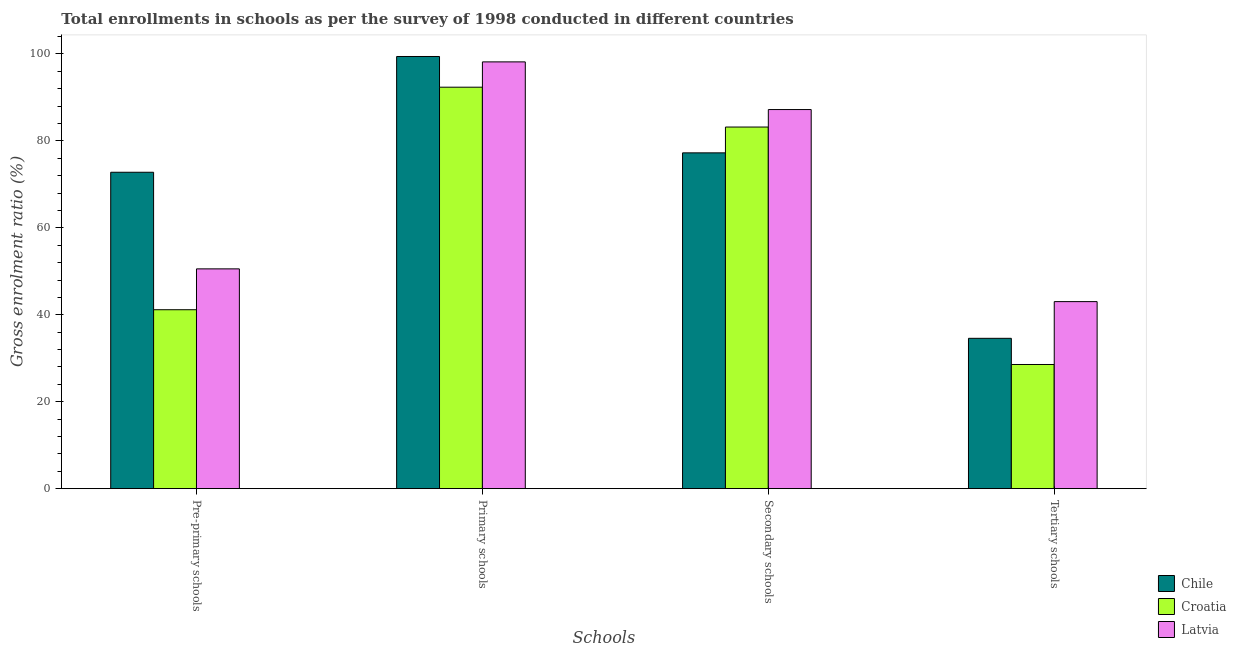How many different coloured bars are there?
Provide a succinct answer. 3. Are the number of bars on each tick of the X-axis equal?
Make the answer very short. Yes. How many bars are there on the 4th tick from the left?
Your response must be concise. 3. What is the label of the 4th group of bars from the left?
Make the answer very short. Tertiary schools. What is the gross enrolment ratio in secondary schools in Latvia?
Give a very brief answer. 87.21. Across all countries, what is the maximum gross enrolment ratio in primary schools?
Your response must be concise. 99.42. Across all countries, what is the minimum gross enrolment ratio in tertiary schools?
Your answer should be very brief. 28.57. In which country was the gross enrolment ratio in secondary schools maximum?
Make the answer very short. Latvia. In which country was the gross enrolment ratio in secondary schools minimum?
Provide a succinct answer. Chile. What is the total gross enrolment ratio in pre-primary schools in the graph?
Keep it short and to the point. 164.52. What is the difference between the gross enrolment ratio in tertiary schools in Croatia and that in Chile?
Your response must be concise. -6.02. What is the difference between the gross enrolment ratio in tertiary schools in Croatia and the gross enrolment ratio in secondary schools in Chile?
Keep it short and to the point. -48.68. What is the average gross enrolment ratio in pre-primary schools per country?
Your answer should be very brief. 54.84. What is the difference between the gross enrolment ratio in primary schools and gross enrolment ratio in pre-primary schools in Croatia?
Your answer should be very brief. 51.19. What is the ratio of the gross enrolment ratio in tertiary schools in Latvia to that in Croatia?
Offer a terse response. 1.51. What is the difference between the highest and the second highest gross enrolment ratio in tertiary schools?
Offer a terse response. 8.44. What is the difference between the highest and the lowest gross enrolment ratio in primary schools?
Ensure brevity in your answer.  7.06. In how many countries, is the gross enrolment ratio in primary schools greater than the average gross enrolment ratio in primary schools taken over all countries?
Provide a short and direct response. 2. Is the sum of the gross enrolment ratio in tertiary schools in Latvia and Chile greater than the maximum gross enrolment ratio in secondary schools across all countries?
Provide a short and direct response. No. Is it the case that in every country, the sum of the gross enrolment ratio in primary schools and gross enrolment ratio in secondary schools is greater than the sum of gross enrolment ratio in tertiary schools and gross enrolment ratio in pre-primary schools?
Offer a very short reply. Yes. What does the 3rd bar from the left in Tertiary schools represents?
Offer a terse response. Latvia. What does the 2nd bar from the right in Tertiary schools represents?
Your answer should be very brief. Croatia. How many bars are there?
Keep it short and to the point. 12. Are the values on the major ticks of Y-axis written in scientific E-notation?
Provide a short and direct response. No. Does the graph contain grids?
Provide a succinct answer. No. Where does the legend appear in the graph?
Your answer should be very brief. Bottom right. How many legend labels are there?
Offer a very short reply. 3. What is the title of the graph?
Ensure brevity in your answer.  Total enrollments in schools as per the survey of 1998 conducted in different countries. What is the label or title of the X-axis?
Give a very brief answer. Schools. What is the label or title of the Y-axis?
Your answer should be very brief. Gross enrolment ratio (%). What is the Gross enrolment ratio (%) of Chile in Pre-primary schools?
Your response must be concise. 72.79. What is the Gross enrolment ratio (%) of Croatia in Pre-primary schools?
Ensure brevity in your answer.  41.17. What is the Gross enrolment ratio (%) of Latvia in Pre-primary schools?
Make the answer very short. 50.57. What is the Gross enrolment ratio (%) of Chile in Primary schools?
Offer a terse response. 99.42. What is the Gross enrolment ratio (%) of Croatia in Primary schools?
Offer a terse response. 92.35. What is the Gross enrolment ratio (%) in Latvia in Primary schools?
Make the answer very short. 98.18. What is the Gross enrolment ratio (%) of Chile in Secondary schools?
Your answer should be very brief. 77.25. What is the Gross enrolment ratio (%) in Croatia in Secondary schools?
Offer a very short reply. 83.19. What is the Gross enrolment ratio (%) in Latvia in Secondary schools?
Offer a very short reply. 87.21. What is the Gross enrolment ratio (%) of Chile in Tertiary schools?
Offer a very short reply. 34.59. What is the Gross enrolment ratio (%) of Croatia in Tertiary schools?
Ensure brevity in your answer.  28.57. What is the Gross enrolment ratio (%) of Latvia in Tertiary schools?
Provide a short and direct response. 43.03. Across all Schools, what is the maximum Gross enrolment ratio (%) of Chile?
Keep it short and to the point. 99.42. Across all Schools, what is the maximum Gross enrolment ratio (%) of Croatia?
Offer a terse response. 92.35. Across all Schools, what is the maximum Gross enrolment ratio (%) in Latvia?
Provide a short and direct response. 98.18. Across all Schools, what is the minimum Gross enrolment ratio (%) of Chile?
Your answer should be very brief. 34.59. Across all Schools, what is the minimum Gross enrolment ratio (%) of Croatia?
Give a very brief answer. 28.57. Across all Schools, what is the minimum Gross enrolment ratio (%) in Latvia?
Ensure brevity in your answer.  43.03. What is the total Gross enrolment ratio (%) in Chile in the graph?
Keep it short and to the point. 284.04. What is the total Gross enrolment ratio (%) of Croatia in the graph?
Provide a short and direct response. 245.28. What is the total Gross enrolment ratio (%) in Latvia in the graph?
Make the answer very short. 278.98. What is the difference between the Gross enrolment ratio (%) of Chile in Pre-primary schools and that in Primary schools?
Offer a very short reply. -26.63. What is the difference between the Gross enrolment ratio (%) of Croatia in Pre-primary schools and that in Primary schools?
Give a very brief answer. -51.19. What is the difference between the Gross enrolment ratio (%) in Latvia in Pre-primary schools and that in Primary schools?
Offer a terse response. -47.61. What is the difference between the Gross enrolment ratio (%) of Chile in Pre-primary schools and that in Secondary schools?
Provide a succinct answer. -4.46. What is the difference between the Gross enrolment ratio (%) in Croatia in Pre-primary schools and that in Secondary schools?
Keep it short and to the point. -42.02. What is the difference between the Gross enrolment ratio (%) in Latvia in Pre-primary schools and that in Secondary schools?
Your response must be concise. -36.65. What is the difference between the Gross enrolment ratio (%) in Chile in Pre-primary schools and that in Tertiary schools?
Keep it short and to the point. 38.2. What is the difference between the Gross enrolment ratio (%) in Croatia in Pre-primary schools and that in Tertiary schools?
Ensure brevity in your answer.  12.6. What is the difference between the Gross enrolment ratio (%) of Latvia in Pre-primary schools and that in Tertiary schools?
Offer a terse response. 7.54. What is the difference between the Gross enrolment ratio (%) in Chile in Primary schools and that in Secondary schools?
Give a very brief answer. 22.17. What is the difference between the Gross enrolment ratio (%) in Croatia in Primary schools and that in Secondary schools?
Your answer should be compact. 9.16. What is the difference between the Gross enrolment ratio (%) of Latvia in Primary schools and that in Secondary schools?
Offer a terse response. 10.97. What is the difference between the Gross enrolment ratio (%) of Chile in Primary schools and that in Tertiary schools?
Your response must be concise. 64.83. What is the difference between the Gross enrolment ratio (%) of Croatia in Primary schools and that in Tertiary schools?
Your answer should be compact. 63.79. What is the difference between the Gross enrolment ratio (%) of Latvia in Primary schools and that in Tertiary schools?
Your answer should be compact. 55.15. What is the difference between the Gross enrolment ratio (%) in Chile in Secondary schools and that in Tertiary schools?
Provide a short and direct response. 42.66. What is the difference between the Gross enrolment ratio (%) in Croatia in Secondary schools and that in Tertiary schools?
Provide a succinct answer. 54.62. What is the difference between the Gross enrolment ratio (%) of Latvia in Secondary schools and that in Tertiary schools?
Your answer should be very brief. 44.18. What is the difference between the Gross enrolment ratio (%) of Chile in Pre-primary schools and the Gross enrolment ratio (%) of Croatia in Primary schools?
Give a very brief answer. -19.57. What is the difference between the Gross enrolment ratio (%) in Chile in Pre-primary schools and the Gross enrolment ratio (%) in Latvia in Primary schools?
Provide a short and direct response. -25.39. What is the difference between the Gross enrolment ratio (%) in Croatia in Pre-primary schools and the Gross enrolment ratio (%) in Latvia in Primary schools?
Your answer should be compact. -57.01. What is the difference between the Gross enrolment ratio (%) in Chile in Pre-primary schools and the Gross enrolment ratio (%) in Croatia in Secondary schools?
Ensure brevity in your answer.  -10.41. What is the difference between the Gross enrolment ratio (%) in Chile in Pre-primary schools and the Gross enrolment ratio (%) in Latvia in Secondary schools?
Provide a short and direct response. -14.42. What is the difference between the Gross enrolment ratio (%) in Croatia in Pre-primary schools and the Gross enrolment ratio (%) in Latvia in Secondary schools?
Make the answer very short. -46.04. What is the difference between the Gross enrolment ratio (%) of Chile in Pre-primary schools and the Gross enrolment ratio (%) of Croatia in Tertiary schools?
Provide a short and direct response. 44.22. What is the difference between the Gross enrolment ratio (%) in Chile in Pre-primary schools and the Gross enrolment ratio (%) in Latvia in Tertiary schools?
Your answer should be very brief. 29.76. What is the difference between the Gross enrolment ratio (%) in Croatia in Pre-primary schools and the Gross enrolment ratio (%) in Latvia in Tertiary schools?
Ensure brevity in your answer.  -1.86. What is the difference between the Gross enrolment ratio (%) in Chile in Primary schools and the Gross enrolment ratio (%) in Croatia in Secondary schools?
Make the answer very short. 16.23. What is the difference between the Gross enrolment ratio (%) in Chile in Primary schools and the Gross enrolment ratio (%) in Latvia in Secondary schools?
Make the answer very short. 12.21. What is the difference between the Gross enrolment ratio (%) in Croatia in Primary schools and the Gross enrolment ratio (%) in Latvia in Secondary schools?
Your answer should be very brief. 5.14. What is the difference between the Gross enrolment ratio (%) in Chile in Primary schools and the Gross enrolment ratio (%) in Croatia in Tertiary schools?
Your response must be concise. 70.85. What is the difference between the Gross enrolment ratio (%) in Chile in Primary schools and the Gross enrolment ratio (%) in Latvia in Tertiary schools?
Provide a succinct answer. 56.39. What is the difference between the Gross enrolment ratio (%) of Croatia in Primary schools and the Gross enrolment ratio (%) of Latvia in Tertiary schools?
Offer a terse response. 49.33. What is the difference between the Gross enrolment ratio (%) of Chile in Secondary schools and the Gross enrolment ratio (%) of Croatia in Tertiary schools?
Provide a succinct answer. 48.68. What is the difference between the Gross enrolment ratio (%) of Chile in Secondary schools and the Gross enrolment ratio (%) of Latvia in Tertiary schools?
Offer a very short reply. 34.22. What is the difference between the Gross enrolment ratio (%) in Croatia in Secondary schools and the Gross enrolment ratio (%) in Latvia in Tertiary schools?
Make the answer very short. 40.16. What is the average Gross enrolment ratio (%) of Chile per Schools?
Make the answer very short. 71.01. What is the average Gross enrolment ratio (%) of Croatia per Schools?
Keep it short and to the point. 61.32. What is the average Gross enrolment ratio (%) of Latvia per Schools?
Make the answer very short. 69.75. What is the difference between the Gross enrolment ratio (%) in Chile and Gross enrolment ratio (%) in Croatia in Pre-primary schools?
Your response must be concise. 31.62. What is the difference between the Gross enrolment ratio (%) in Chile and Gross enrolment ratio (%) in Latvia in Pre-primary schools?
Your response must be concise. 22.22. What is the difference between the Gross enrolment ratio (%) in Croatia and Gross enrolment ratio (%) in Latvia in Pre-primary schools?
Your response must be concise. -9.4. What is the difference between the Gross enrolment ratio (%) in Chile and Gross enrolment ratio (%) in Croatia in Primary schools?
Keep it short and to the point. 7.06. What is the difference between the Gross enrolment ratio (%) in Chile and Gross enrolment ratio (%) in Latvia in Primary schools?
Your answer should be compact. 1.24. What is the difference between the Gross enrolment ratio (%) of Croatia and Gross enrolment ratio (%) of Latvia in Primary schools?
Provide a short and direct response. -5.82. What is the difference between the Gross enrolment ratio (%) of Chile and Gross enrolment ratio (%) of Croatia in Secondary schools?
Keep it short and to the point. -5.94. What is the difference between the Gross enrolment ratio (%) in Chile and Gross enrolment ratio (%) in Latvia in Secondary schools?
Provide a short and direct response. -9.96. What is the difference between the Gross enrolment ratio (%) in Croatia and Gross enrolment ratio (%) in Latvia in Secondary schools?
Keep it short and to the point. -4.02. What is the difference between the Gross enrolment ratio (%) of Chile and Gross enrolment ratio (%) of Croatia in Tertiary schools?
Offer a very short reply. 6.02. What is the difference between the Gross enrolment ratio (%) of Chile and Gross enrolment ratio (%) of Latvia in Tertiary schools?
Give a very brief answer. -8.44. What is the difference between the Gross enrolment ratio (%) in Croatia and Gross enrolment ratio (%) in Latvia in Tertiary schools?
Offer a terse response. -14.46. What is the ratio of the Gross enrolment ratio (%) of Chile in Pre-primary schools to that in Primary schools?
Offer a very short reply. 0.73. What is the ratio of the Gross enrolment ratio (%) in Croatia in Pre-primary schools to that in Primary schools?
Give a very brief answer. 0.45. What is the ratio of the Gross enrolment ratio (%) in Latvia in Pre-primary schools to that in Primary schools?
Keep it short and to the point. 0.52. What is the ratio of the Gross enrolment ratio (%) of Chile in Pre-primary schools to that in Secondary schools?
Keep it short and to the point. 0.94. What is the ratio of the Gross enrolment ratio (%) of Croatia in Pre-primary schools to that in Secondary schools?
Your response must be concise. 0.49. What is the ratio of the Gross enrolment ratio (%) of Latvia in Pre-primary schools to that in Secondary schools?
Your response must be concise. 0.58. What is the ratio of the Gross enrolment ratio (%) of Chile in Pre-primary schools to that in Tertiary schools?
Keep it short and to the point. 2.1. What is the ratio of the Gross enrolment ratio (%) in Croatia in Pre-primary schools to that in Tertiary schools?
Your answer should be compact. 1.44. What is the ratio of the Gross enrolment ratio (%) in Latvia in Pre-primary schools to that in Tertiary schools?
Your response must be concise. 1.18. What is the ratio of the Gross enrolment ratio (%) in Chile in Primary schools to that in Secondary schools?
Ensure brevity in your answer.  1.29. What is the ratio of the Gross enrolment ratio (%) of Croatia in Primary schools to that in Secondary schools?
Your answer should be very brief. 1.11. What is the ratio of the Gross enrolment ratio (%) of Latvia in Primary schools to that in Secondary schools?
Offer a terse response. 1.13. What is the ratio of the Gross enrolment ratio (%) in Chile in Primary schools to that in Tertiary schools?
Offer a very short reply. 2.87. What is the ratio of the Gross enrolment ratio (%) in Croatia in Primary schools to that in Tertiary schools?
Offer a terse response. 3.23. What is the ratio of the Gross enrolment ratio (%) in Latvia in Primary schools to that in Tertiary schools?
Your response must be concise. 2.28. What is the ratio of the Gross enrolment ratio (%) of Chile in Secondary schools to that in Tertiary schools?
Give a very brief answer. 2.23. What is the ratio of the Gross enrolment ratio (%) of Croatia in Secondary schools to that in Tertiary schools?
Ensure brevity in your answer.  2.91. What is the ratio of the Gross enrolment ratio (%) of Latvia in Secondary schools to that in Tertiary schools?
Offer a very short reply. 2.03. What is the difference between the highest and the second highest Gross enrolment ratio (%) in Chile?
Provide a succinct answer. 22.17. What is the difference between the highest and the second highest Gross enrolment ratio (%) of Croatia?
Give a very brief answer. 9.16. What is the difference between the highest and the second highest Gross enrolment ratio (%) of Latvia?
Offer a very short reply. 10.97. What is the difference between the highest and the lowest Gross enrolment ratio (%) of Chile?
Offer a terse response. 64.83. What is the difference between the highest and the lowest Gross enrolment ratio (%) in Croatia?
Provide a succinct answer. 63.79. What is the difference between the highest and the lowest Gross enrolment ratio (%) of Latvia?
Your response must be concise. 55.15. 